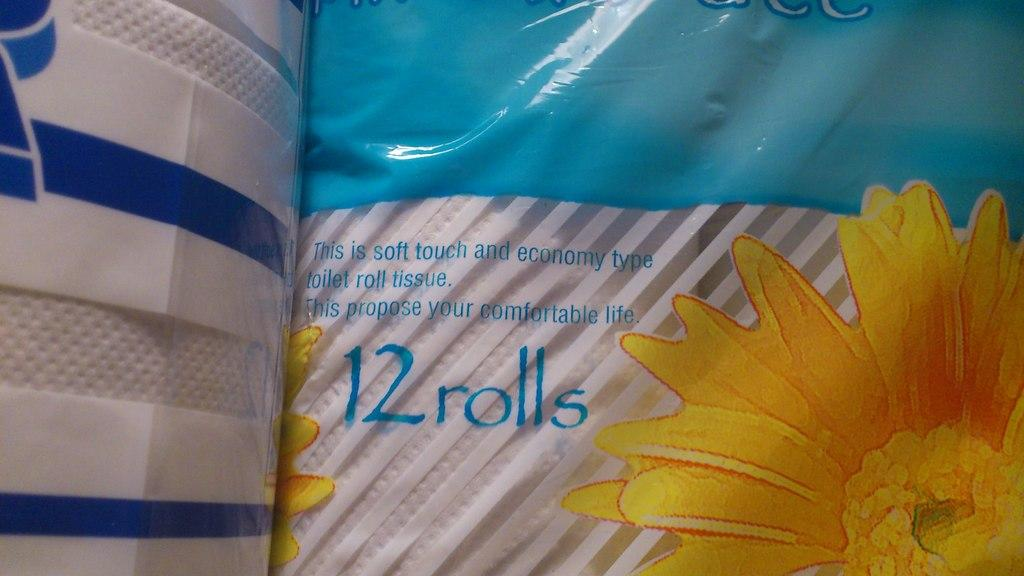What is the main subject of the image? The main subject of the image is tissue roll covers. Can you describe the tissue roll covers in the image? The image is a zoomed in picture of tissue roll covers. Is there any text visible on the tissue roll covers? Yes, there is text visible in the image. What type of trail can be seen in the image? There is no trail present in the image; it features tissue roll covers with text. What kind of mailbox is visible in the image? There is no mailbox present in the image; it features tissue roll covers with text. 